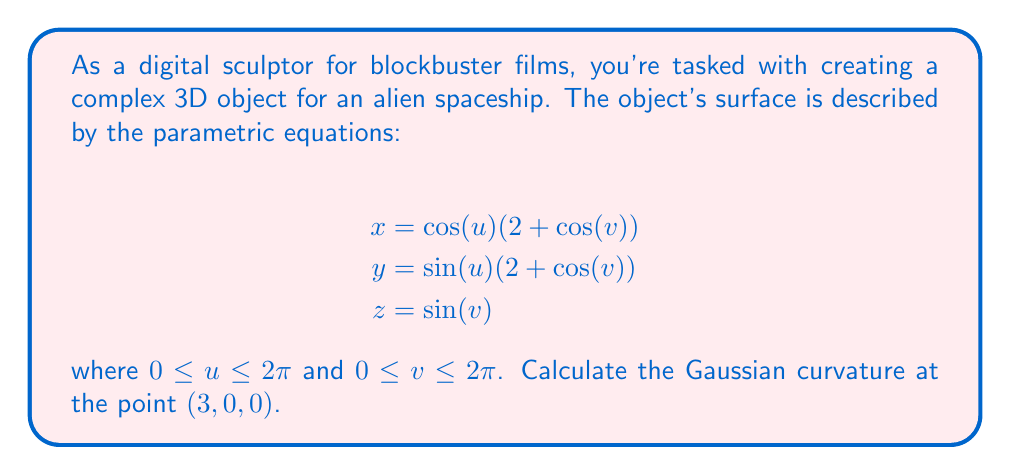Provide a solution to this math problem. To calculate the Gaussian curvature, we'll follow these steps:

1) First, we need to find the partial derivatives:
   $$\frac{\partial x}{\partial u} = -\sin(u)(2 + \cos(v))$$
   $$\frac{\partial x}{\partial v} = -\cos(u)\sin(v)$$
   $$\frac{\partial y}{\partial u} = \cos(u)(2 + \cos(v))$$
   $$\frac{\partial y}{\partial v} = -\sin(u)\sin(v)$$
   $$\frac{\partial z}{\partial u} = 0$$
   $$\frac{\partial z}{\partial v} = \cos(v)$$

2) Now, we calculate the coefficients of the first fundamental form:
   $$E = (\frac{\partial x}{\partial u})^2 + (\frac{\partial y}{\partial u})^2 + (\frac{\partial z}{\partial u})^2 = (2 + \cos(v))^2$$
   $$F = \frac{\partial x}{\partial u}\frac{\partial x}{\partial v} + \frac{\partial y}{\partial u}\frac{\partial y}{\partial v} + \frac{\partial z}{\partial u}\frac{\partial z}{\partial v} = 0$$
   $$G = (\frac{\partial x}{\partial v})^2 + (\frac{\partial y}{\partial v})^2 + (\frac{\partial z}{\partial v})^2 = \sin^2(v) + \cos^2(v) = 1$$

3) Next, we calculate the second partial derivatives:
   $$\frac{\partial^2 x}{\partial u^2} = -\cos(u)(2 + \cos(v))$$
   $$\frac{\partial^2 x}{\partial u\partial v} = \sin(u)\sin(v)$$
   $$\frac{\partial^2 x}{\partial v^2} = -\cos(u)\cos(v)$$
   $$\frac{\partial^2 y}{\partial u^2} = -\sin(u)(2 + \cos(v))$$
   $$\frac{\partial^2 y}{\partial u\partial v} = -\cos(u)\sin(v)$$
   $$\frac{\partial^2 y}{\partial v^2} = -\sin(u)\cos(v)$$
   $$\frac{\partial^2 z}{\partial u^2} = 0$$
   $$\frac{\partial^2 z}{\partial u\partial v} = 0$$
   $$\frac{\partial^2 z}{\partial v^2} = -\sin(v)$$

4) Now we can calculate the coefficients of the second fundamental form:
   $$L = \frac{\partial^2 x}{\partial u^2}\frac{\partial y}{\partial v}\frac{\partial z}{\partial u} + \frac{\partial^2 y}{\partial u^2}\frac{\partial z}{\partial v}\frac{\partial x}{\partial u} + \frac{\partial^2 z}{\partial u^2}\frac{\partial x}{\partial v}\frac{\partial y}{\partial u} - \frac{\partial^2 x}{\partial u^2}\frac{\partial z}{\partial v}\frac{\partial y}{\partial u} - \frac{\partial^2 y}{\partial u^2}\frac{\partial x}{\partial v}\frac{\partial z}{\partial u} - \frac{\partial^2 z}{\partial u^2}\frac{\partial y}{\partial v}\frac{\partial x}{\partial u} = 0$$
   $$M = \frac{\partial^2 x}{\partial u\partial v}\frac{\partial y}{\partial v}\frac{\partial z}{\partial u} + \frac{\partial^2 y}{\partial u\partial v}\frac{\partial z}{\partial v}\frac{\partial x}{\partial u} + \frac{\partial^2 z}{\partial u\partial v}\frac{\partial x}{\partial v}\frac{\partial y}{\partial u} - \frac{\partial^2 x}{\partial u\partial v}\frac{\partial z}{\partial v}\frac{\partial y}{\partial u} - \frac{\partial^2 y}{\partial u\partial v}\frac{\partial x}{\partial v}\frac{\partial z}{\partial u} - \frac{\partial^2 z}{\partial u\partial v}\frac{\partial y}{\partial v}\frac{\partial x}{\partial u} = -(2 + \cos(v))$$
   $$N = \frac{\partial^2 x}{\partial v^2}\frac{\partial y}{\partial v}\frac{\partial z}{\partial u} + \frac{\partial^2 y}{\partial v^2}\frac{\partial z}{\partial v}\frac{\partial x}{\partial u} + \frac{\partial^2 z}{\partial v^2}\frac{\partial x}{\partial v}\frac{\partial y}{\partial u} - \frac{\partial^2 x}{\partial v^2}\frac{\partial z}{\partial v}\frac{\partial y}{\partial u} - \frac{\partial^2 y}{\partial v^2}\frac{\partial x}{\partial v}\frac{\partial z}{\partial u} - \frac{\partial^2 z}{\partial v^2}\frac{\partial y}{\partial v}\frac{\partial x}{\partial u} = -(2 + \cos(v))$$

5) The Gaussian curvature is given by:
   $$K = \frac{LN - M^2}{EG - F^2}$$

6) At the point $(3, 0, 0)$, we have $u = 0$ and $v = 0$. Substituting these values:
   $$E = 9, F = 0, G = 1$$
   $$L = 0, M = -3, N = -3$$

7) Therefore, the Gaussian curvature at $(3, 0, 0)$ is:
   $$K = \frac{(0)(-3) - (-3)^2}{(9)(1) - 0^2} = \frac{-9}{9} = -1$$
Answer: $K = -1$ 